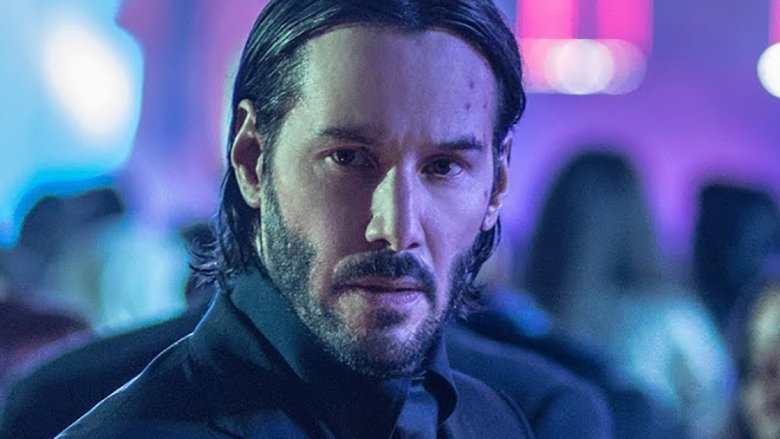How does the lighting affect the visual impact of the image? The lighting in the image plays a crucial role in creating visual impact. The bright, varied colors of the nightclub lights not only illuminate the scene but also help to focus attention on the man in the black suit, making him stand out against the lively background. The way the lights are scattered and reflected off surfaces adds a dynamic element, enhancing the dramatic and energetic feel of the scene. 